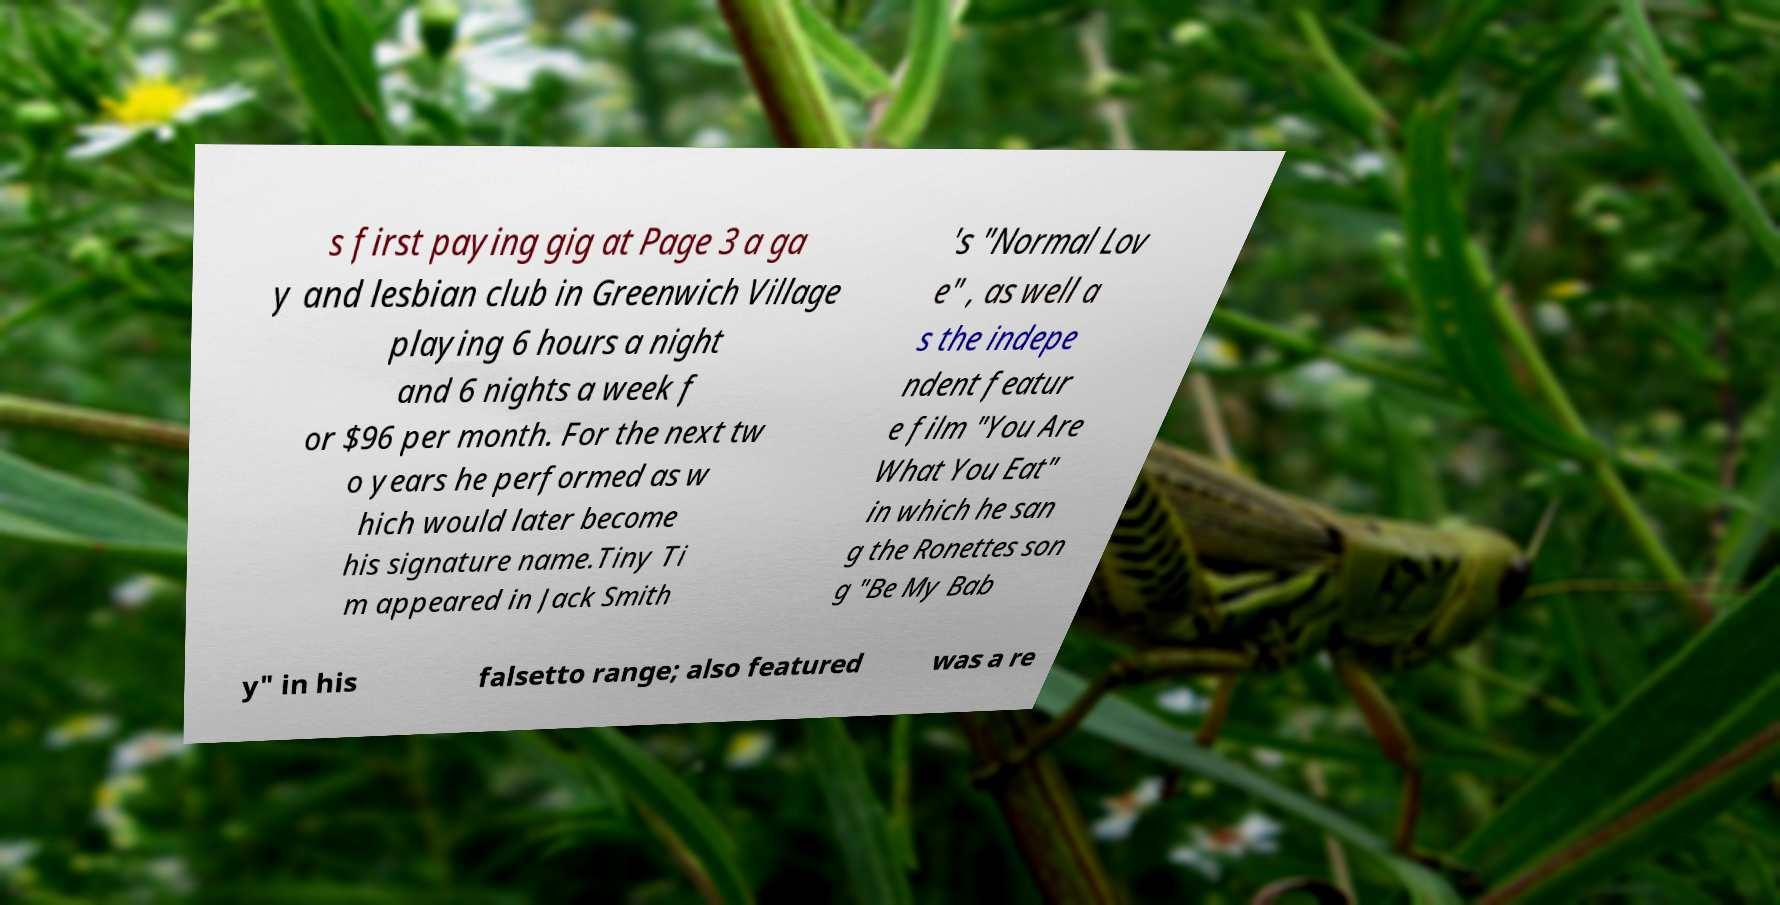Could you extract and type out the text from this image? s first paying gig at Page 3 a ga y and lesbian club in Greenwich Village playing 6 hours a night and 6 nights a week f or $96 per month. For the next tw o years he performed as w hich would later become his signature name.Tiny Ti m appeared in Jack Smith 's "Normal Lov e" , as well a s the indepe ndent featur e film "You Are What You Eat" in which he san g the Ronettes son g "Be My Bab y" in his falsetto range; also featured was a re 